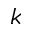<formula> <loc_0><loc_0><loc_500><loc_500>k</formula> 